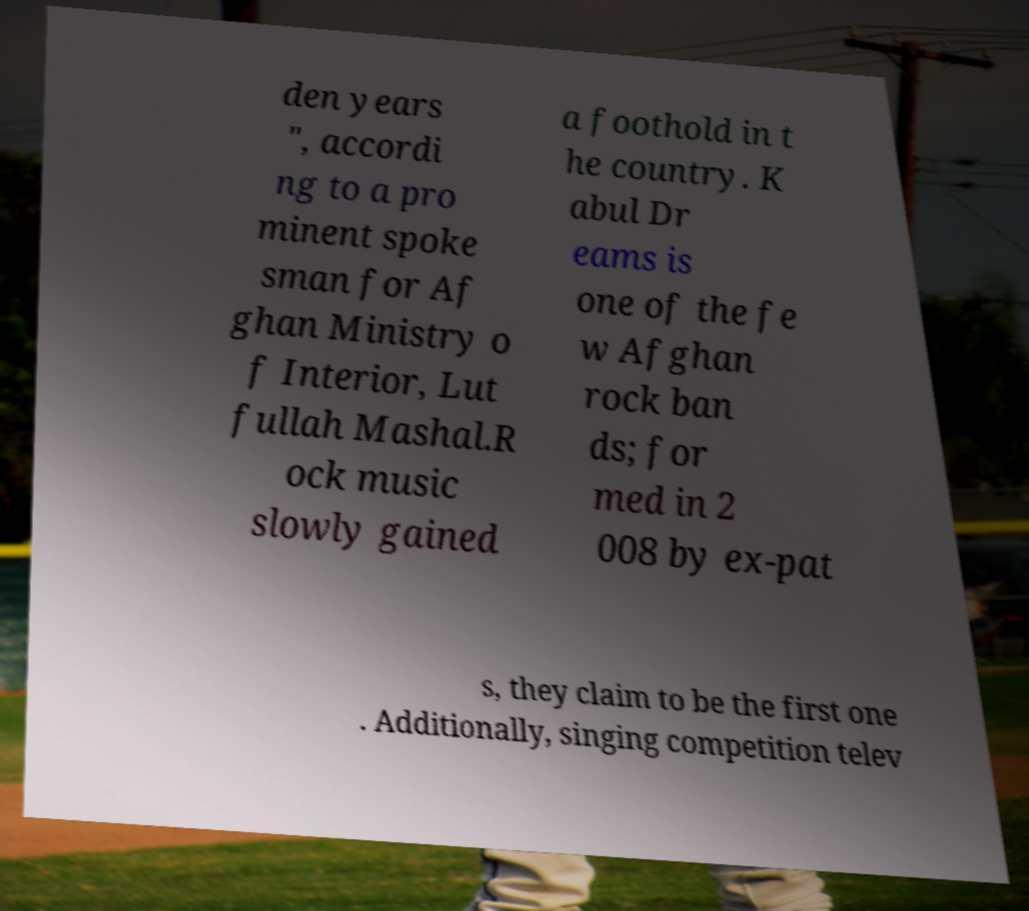For documentation purposes, I need the text within this image transcribed. Could you provide that? den years ", accordi ng to a pro minent spoke sman for Af ghan Ministry o f Interior, Lut fullah Mashal.R ock music slowly gained a foothold in t he country. K abul Dr eams is one of the fe w Afghan rock ban ds; for med in 2 008 by ex-pat s, they claim to be the first one . Additionally, singing competition telev 